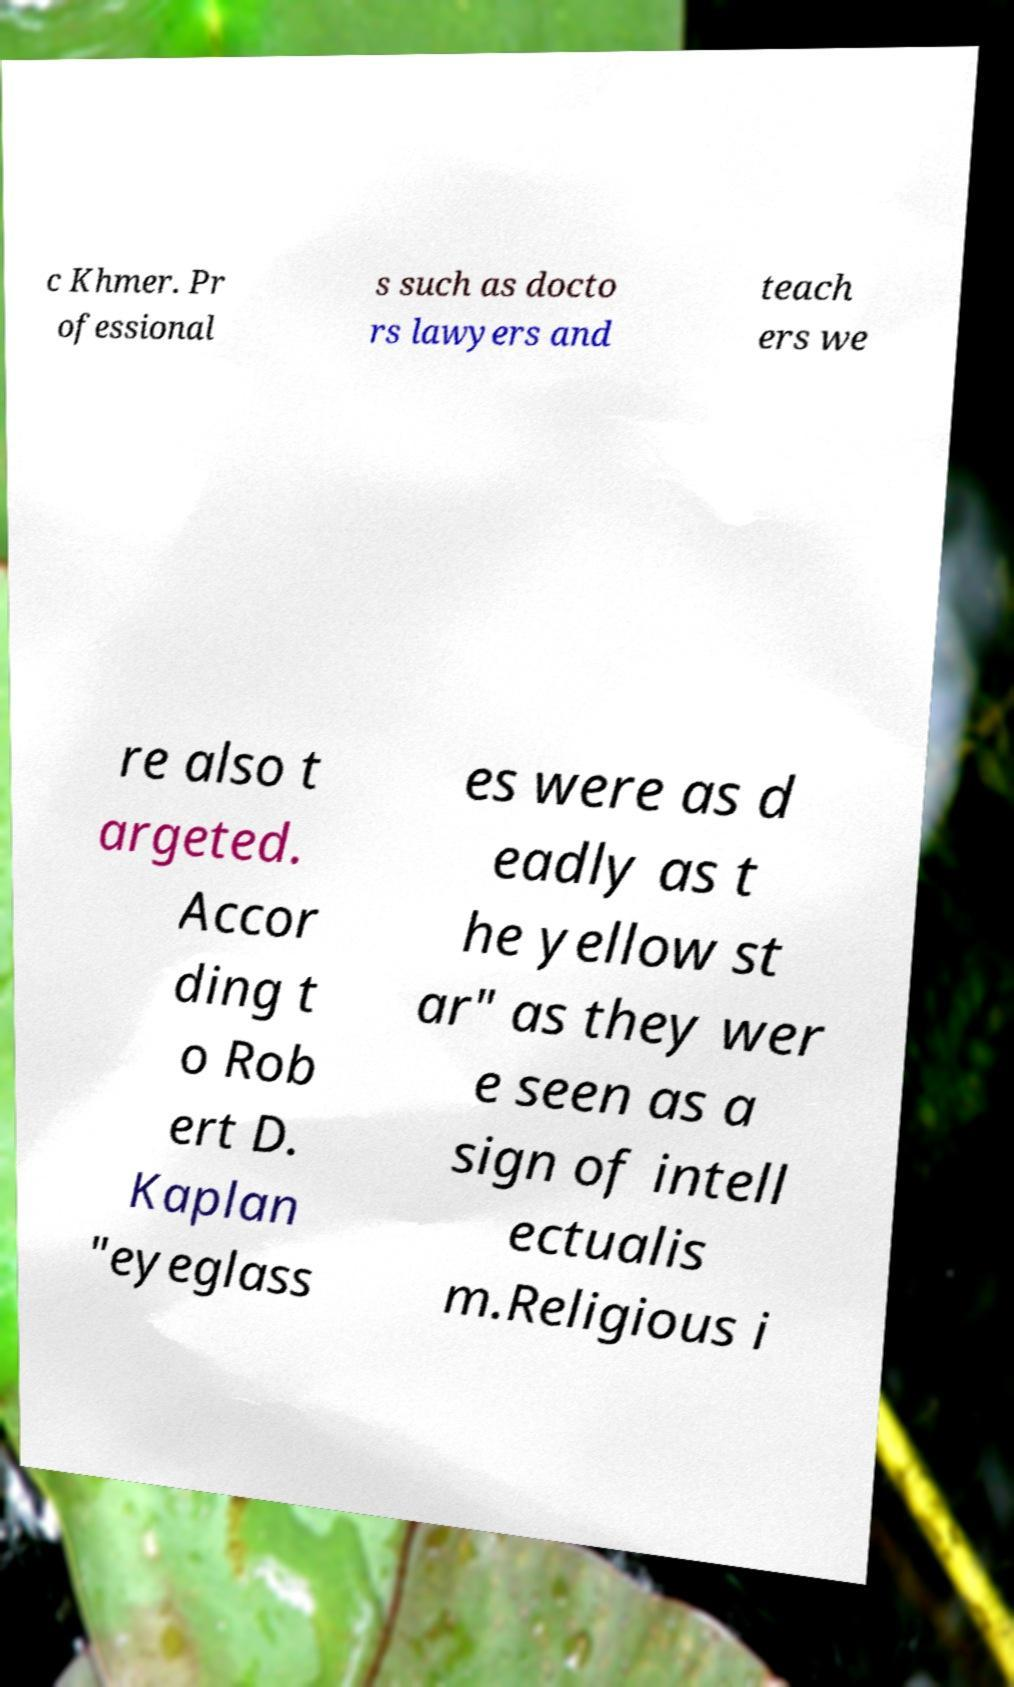Can you accurately transcribe the text from the provided image for me? c Khmer. Pr ofessional s such as docto rs lawyers and teach ers we re also t argeted. Accor ding t o Rob ert D. Kaplan "eyeglass es were as d eadly as t he yellow st ar" as they wer e seen as a sign of intell ectualis m.Religious i 